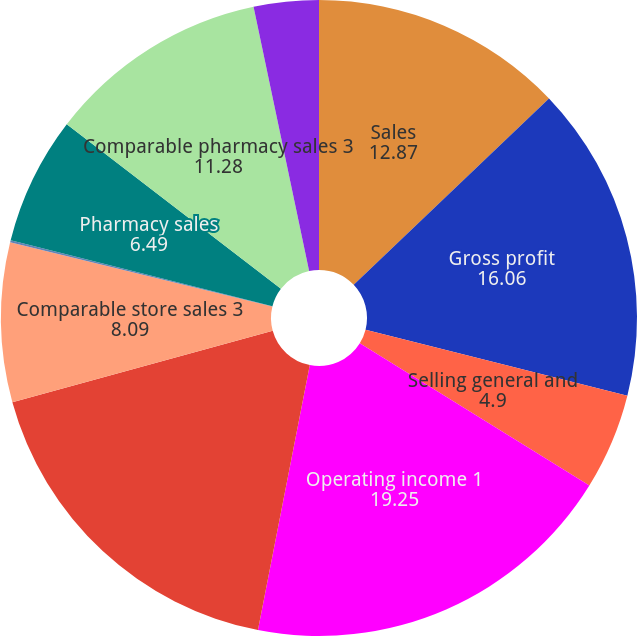Convert chart. <chart><loc_0><loc_0><loc_500><loc_500><pie_chart><fcel>Sales<fcel>Gross profit<fcel>Selling general and<fcel>Operating income 1<fcel>Adjusted operating income<fcel>Comparable store sales 3<fcel>Comparable store sales in<fcel>Pharmacy sales<fcel>Comparable pharmacy sales 3<fcel>Comparable pharmacy sales in<nl><fcel>12.87%<fcel>16.06%<fcel>4.9%<fcel>19.25%<fcel>17.66%<fcel>8.09%<fcel>0.11%<fcel>6.49%<fcel>11.28%<fcel>3.3%<nl></chart> 